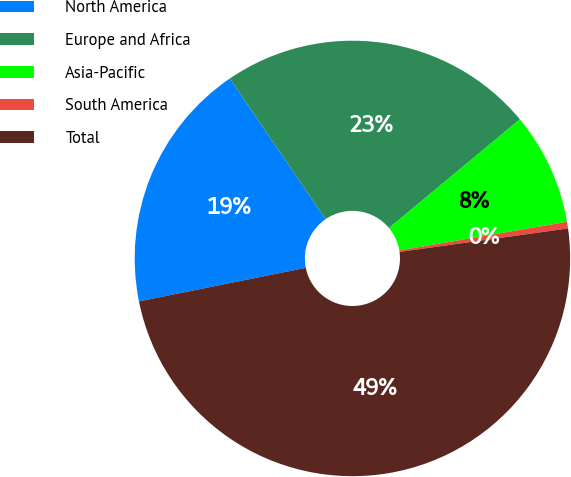Convert chart. <chart><loc_0><loc_0><loc_500><loc_500><pie_chart><fcel>North America<fcel>Europe and Africa<fcel>Asia-Pacific<fcel>South America<fcel>Total<nl><fcel>18.64%<fcel>23.49%<fcel>8.34%<fcel>0.49%<fcel>49.04%<nl></chart> 